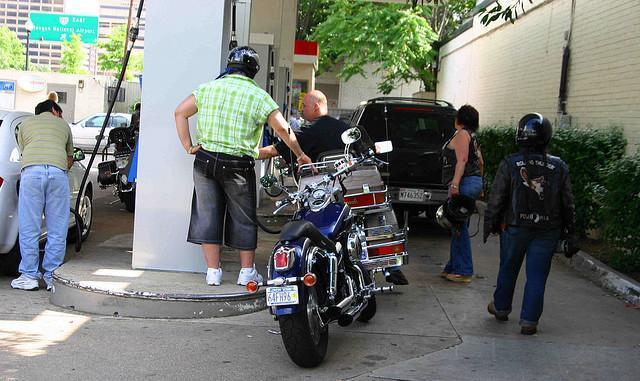How many motorcycles are there?
Give a very brief answer. 3. How many people are there?
Give a very brief answer. 5. 